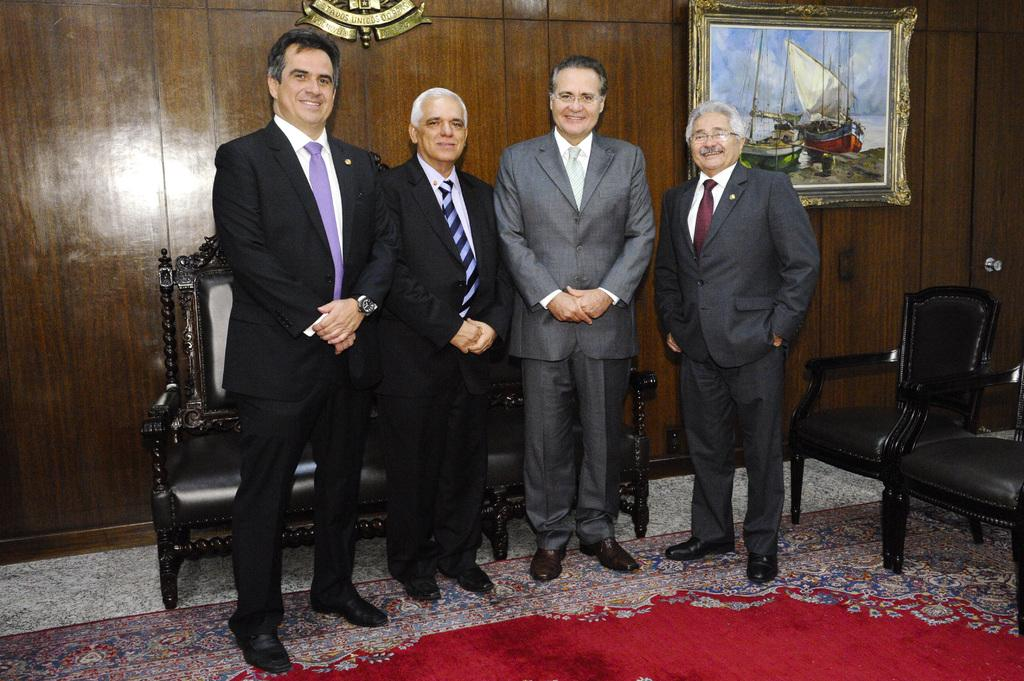How many people are in the image? There are four men in the image. What are the men doing in the image? The men are standing in the image. What are the men wearing in the image? The men are wearing suits in the image. What expressions do the men have in the image? The men are smiling in the image. What can be seen in the background of the image? There are chairs and a frame on the wall in the background of the image. Can you see a squirrel nesting in the frame on the wall in the image? There is no squirrel or nest present in the image. What type of cream is being served on the chairs in the background of the image? There is no cream or chairs visible in the image; only the men, their suits, and the frame on the wall are present. 